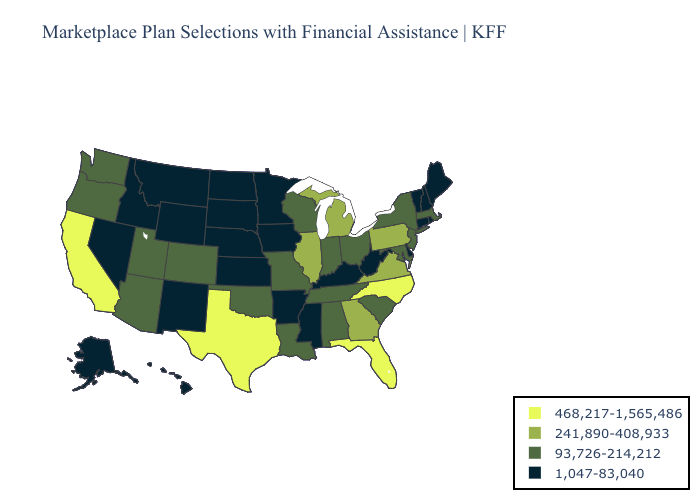Name the states that have a value in the range 241,890-408,933?
Keep it brief. Georgia, Illinois, Michigan, Pennsylvania, Virginia. Name the states that have a value in the range 468,217-1,565,486?
Give a very brief answer. California, Florida, North Carolina, Texas. Does Colorado have the highest value in the USA?
Answer briefly. No. What is the highest value in states that border Oregon?
Answer briefly. 468,217-1,565,486. What is the value of Alaska?
Give a very brief answer. 1,047-83,040. Does California have the highest value in the West?
Give a very brief answer. Yes. Name the states that have a value in the range 241,890-408,933?
Give a very brief answer. Georgia, Illinois, Michigan, Pennsylvania, Virginia. Does Maryland have a lower value than Florida?
Concise answer only. Yes. What is the highest value in the USA?
Write a very short answer. 468,217-1,565,486. Does Ohio have the same value as Arizona?
Quick response, please. Yes. Does California have the highest value in the West?
Give a very brief answer. Yes. Does Pennsylvania have the highest value in the Northeast?
Keep it brief. Yes. Does the first symbol in the legend represent the smallest category?
Be succinct. No. Does Pennsylvania have the highest value in the Northeast?
Write a very short answer. Yes. Is the legend a continuous bar?
Be succinct. No. 